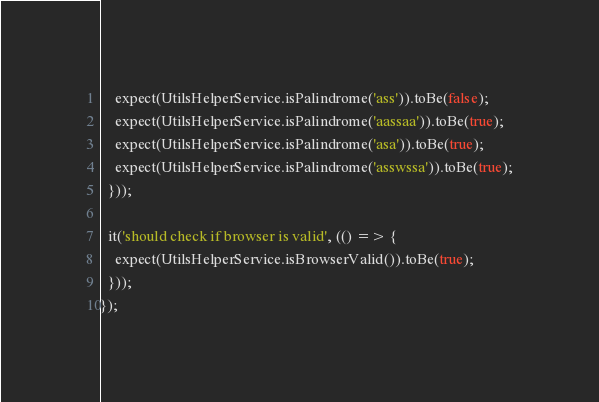<code> <loc_0><loc_0><loc_500><loc_500><_TypeScript_>    expect(UtilsHelperService.isPalindrome('ass')).toBe(false);
    expect(UtilsHelperService.isPalindrome('aassaa')).toBe(true);
    expect(UtilsHelperService.isPalindrome('asa')).toBe(true);
    expect(UtilsHelperService.isPalindrome('asswssa')).toBe(true);
  }));

  it('should check if browser is valid', (() => {
    expect(UtilsHelperService.isBrowserValid()).toBe(true);
  }));
});
</code> 